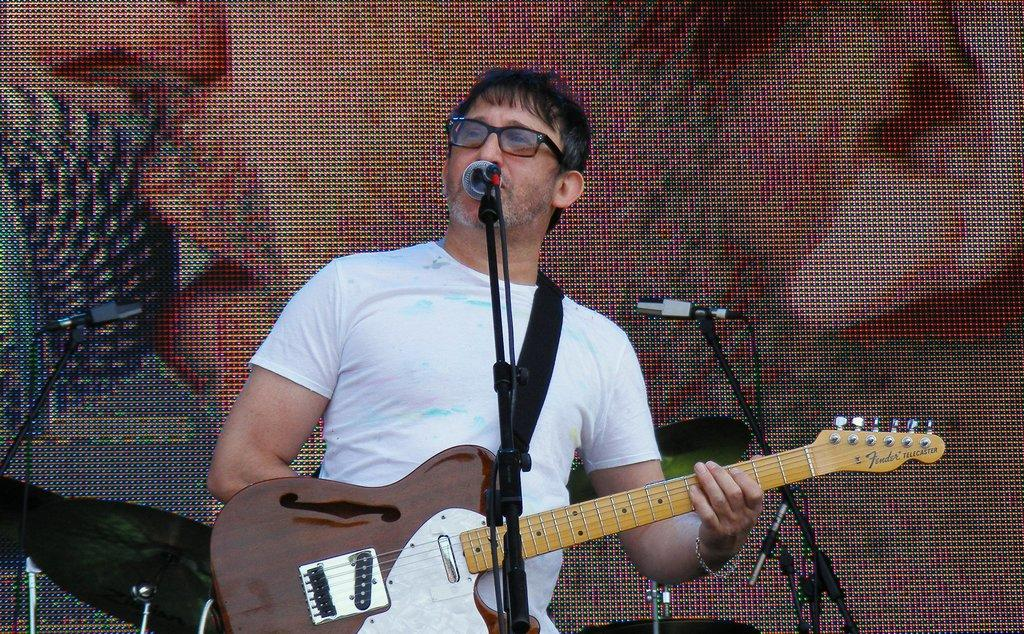What is the main subject of the image? The main subject of the image is a man standing in the center. What is the man holding in his hand? The man is holding a guitar in his hand. What object is in front of the man? There is a microphone (mic) before the man. What can be seen in the background of the image? There is a screen in the background of the image. How much profit did the police make from the order in the image? There is no mention of profit, police, or an order in the image. The image features a man holding a guitar and standing near a microphone and a screen. 